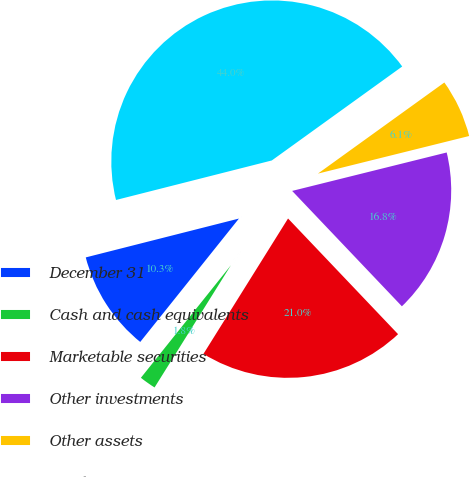<chart> <loc_0><loc_0><loc_500><loc_500><pie_chart><fcel>December 31<fcel>Cash and cash equivalents<fcel>Marketable securities<fcel>Other investments<fcel>Other assets<fcel>Total<nl><fcel>10.31%<fcel>1.85%<fcel>20.99%<fcel>16.78%<fcel>6.06%<fcel>44.02%<nl></chart> 